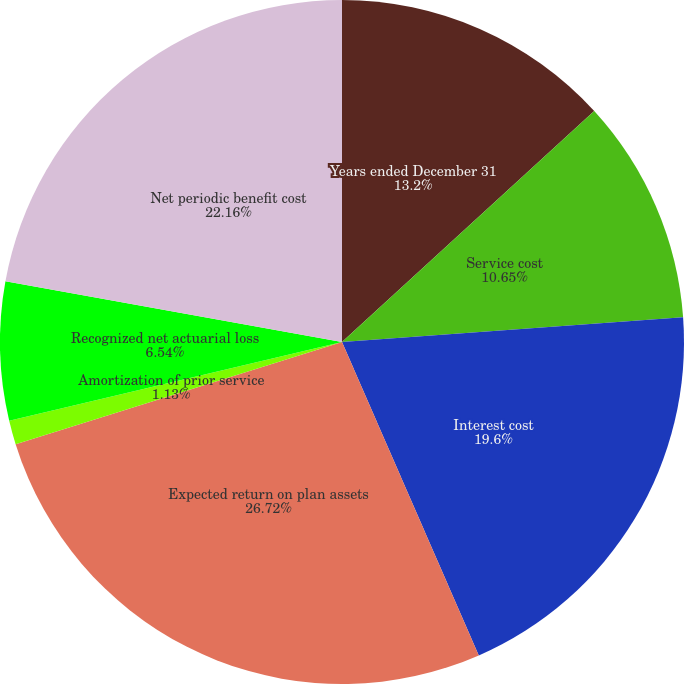<chart> <loc_0><loc_0><loc_500><loc_500><pie_chart><fcel>Years ended December 31<fcel>Service cost<fcel>Interest cost<fcel>Expected return on plan assets<fcel>Amortization of prior service<fcel>Recognized net actuarial loss<fcel>Net periodic benefit cost<nl><fcel>13.2%<fcel>10.65%<fcel>19.6%<fcel>26.72%<fcel>1.13%<fcel>6.54%<fcel>22.16%<nl></chart> 